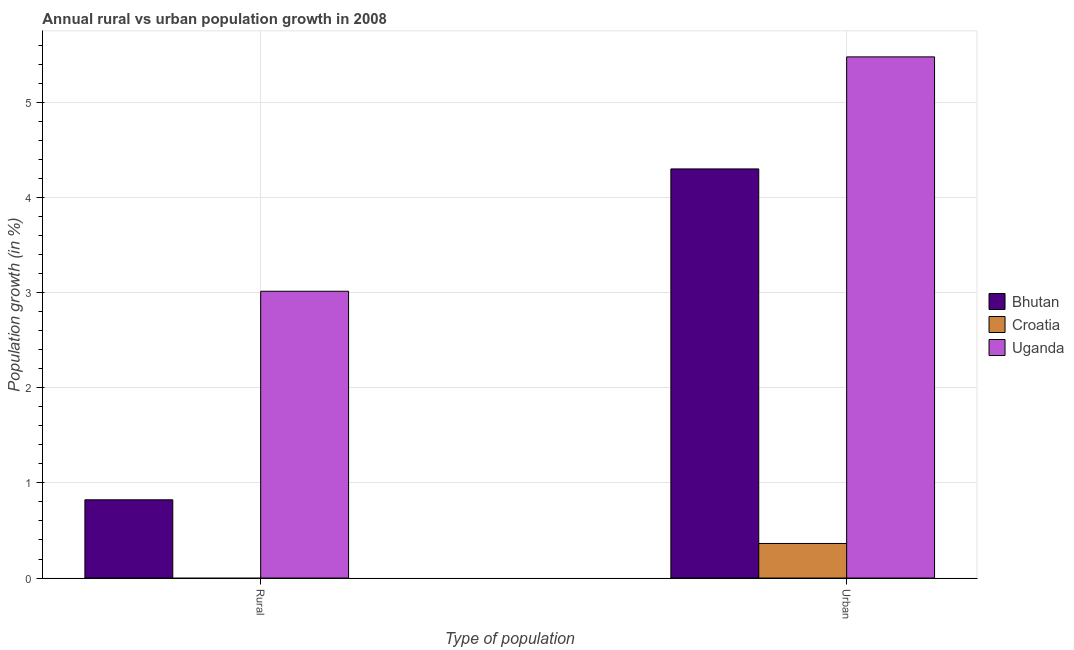How many different coloured bars are there?
Offer a very short reply. 3. Are the number of bars per tick equal to the number of legend labels?
Offer a terse response. No. Are the number of bars on each tick of the X-axis equal?
Your answer should be very brief. No. How many bars are there on the 2nd tick from the right?
Give a very brief answer. 2. What is the label of the 1st group of bars from the left?
Ensure brevity in your answer.  Rural. What is the urban population growth in Croatia?
Give a very brief answer. 0.36. Across all countries, what is the maximum rural population growth?
Ensure brevity in your answer.  3.01. Across all countries, what is the minimum urban population growth?
Your answer should be compact. 0.36. In which country was the urban population growth maximum?
Your answer should be compact. Uganda. What is the total rural population growth in the graph?
Provide a short and direct response. 3.84. What is the difference between the rural population growth in Bhutan and that in Uganda?
Offer a terse response. -2.19. What is the difference between the urban population growth in Croatia and the rural population growth in Bhutan?
Your response must be concise. -0.46. What is the average urban population growth per country?
Keep it short and to the point. 3.38. What is the difference between the urban population growth and rural population growth in Bhutan?
Your answer should be very brief. 3.48. What is the ratio of the urban population growth in Bhutan to that in Croatia?
Your answer should be very brief. 11.83. Is the urban population growth in Croatia less than that in Uganda?
Offer a very short reply. Yes. How many countries are there in the graph?
Ensure brevity in your answer.  3. What is the difference between two consecutive major ticks on the Y-axis?
Provide a short and direct response. 1. Are the values on the major ticks of Y-axis written in scientific E-notation?
Provide a short and direct response. No. Does the graph contain grids?
Your response must be concise. Yes. How are the legend labels stacked?
Your answer should be very brief. Vertical. What is the title of the graph?
Provide a succinct answer. Annual rural vs urban population growth in 2008. Does "Least developed countries" appear as one of the legend labels in the graph?
Your response must be concise. No. What is the label or title of the X-axis?
Provide a succinct answer. Type of population. What is the label or title of the Y-axis?
Provide a succinct answer. Population growth (in %). What is the Population growth (in %) in Bhutan in Rural?
Keep it short and to the point. 0.82. What is the Population growth (in %) of Uganda in Rural?
Offer a terse response. 3.01. What is the Population growth (in %) of Bhutan in Urban ?
Your answer should be very brief. 4.3. What is the Population growth (in %) in Croatia in Urban ?
Provide a succinct answer. 0.36. What is the Population growth (in %) of Uganda in Urban ?
Give a very brief answer. 5.48. Across all Type of population, what is the maximum Population growth (in %) of Bhutan?
Make the answer very short. 4.3. Across all Type of population, what is the maximum Population growth (in %) in Croatia?
Your answer should be very brief. 0.36. Across all Type of population, what is the maximum Population growth (in %) in Uganda?
Make the answer very short. 5.48. Across all Type of population, what is the minimum Population growth (in %) in Bhutan?
Your answer should be very brief. 0.82. Across all Type of population, what is the minimum Population growth (in %) of Croatia?
Provide a short and direct response. 0. Across all Type of population, what is the minimum Population growth (in %) in Uganda?
Offer a very short reply. 3.01. What is the total Population growth (in %) in Bhutan in the graph?
Provide a short and direct response. 5.12. What is the total Population growth (in %) in Croatia in the graph?
Your answer should be very brief. 0.36. What is the total Population growth (in %) of Uganda in the graph?
Your response must be concise. 8.49. What is the difference between the Population growth (in %) in Bhutan in Rural and that in Urban ?
Provide a short and direct response. -3.48. What is the difference between the Population growth (in %) in Uganda in Rural and that in Urban ?
Your answer should be compact. -2.46. What is the difference between the Population growth (in %) of Bhutan in Rural and the Population growth (in %) of Croatia in Urban?
Make the answer very short. 0.46. What is the difference between the Population growth (in %) in Bhutan in Rural and the Population growth (in %) in Uganda in Urban?
Ensure brevity in your answer.  -4.65. What is the average Population growth (in %) in Bhutan per Type of population?
Keep it short and to the point. 2.56. What is the average Population growth (in %) of Croatia per Type of population?
Keep it short and to the point. 0.18. What is the average Population growth (in %) in Uganda per Type of population?
Keep it short and to the point. 4.25. What is the difference between the Population growth (in %) in Bhutan and Population growth (in %) in Uganda in Rural?
Your response must be concise. -2.19. What is the difference between the Population growth (in %) in Bhutan and Population growth (in %) in Croatia in Urban ?
Provide a succinct answer. 3.94. What is the difference between the Population growth (in %) of Bhutan and Population growth (in %) of Uganda in Urban ?
Offer a very short reply. -1.18. What is the difference between the Population growth (in %) of Croatia and Population growth (in %) of Uganda in Urban ?
Give a very brief answer. -5.11. What is the ratio of the Population growth (in %) of Bhutan in Rural to that in Urban ?
Offer a terse response. 0.19. What is the ratio of the Population growth (in %) in Uganda in Rural to that in Urban ?
Give a very brief answer. 0.55. What is the difference between the highest and the second highest Population growth (in %) of Bhutan?
Ensure brevity in your answer.  3.48. What is the difference between the highest and the second highest Population growth (in %) of Uganda?
Provide a succinct answer. 2.46. What is the difference between the highest and the lowest Population growth (in %) in Bhutan?
Your answer should be very brief. 3.48. What is the difference between the highest and the lowest Population growth (in %) of Croatia?
Your answer should be compact. 0.36. What is the difference between the highest and the lowest Population growth (in %) in Uganda?
Offer a very short reply. 2.46. 